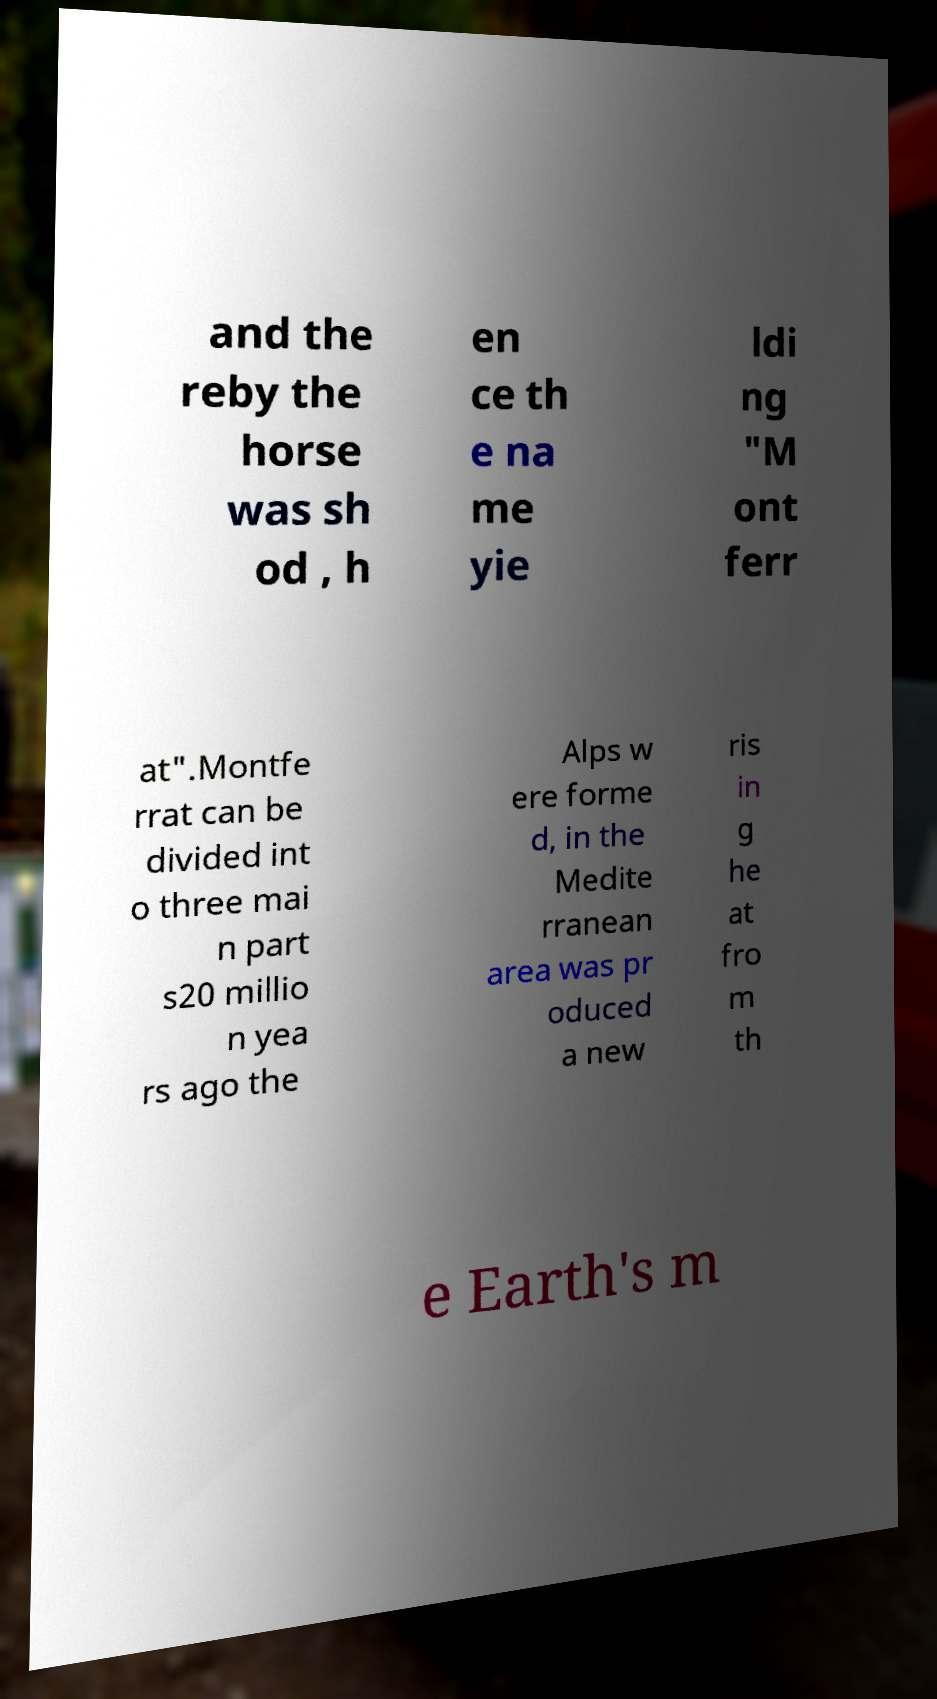Please read and relay the text visible in this image. What does it say? and the reby the horse was sh od , h en ce th e na me yie ldi ng "M ont ferr at".Montfe rrat can be divided int o three mai n part s20 millio n yea rs ago the Alps w ere forme d, in the Medite rranean area was pr oduced a new ris in g he at fro m th e Earth's m 